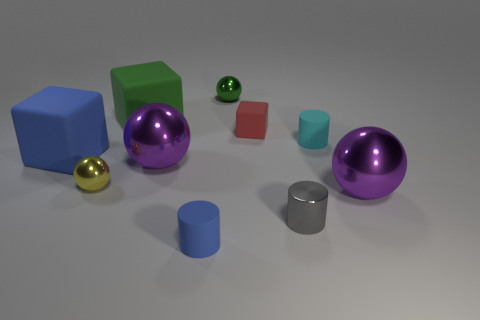Subtract all tiny blue rubber cylinders. How many cylinders are left? 2 Subtract 1 blocks. How many blocks are left? 2 Subtract all balls. How many objects are left? 6 Subtract all purple cylinders. How many purple balls are left? 2 Subtract all blue cylinders. How many cylinders are left? 2 Subtract all red blocks. Subtract all purple cylinders. How many blocks are left? 2 Subtract all tiny cyan objects. Subtract all cyan rubber cylinders. How many objects are left? 8 Add 1 gray metal cylinders. How many gray metal cylinders are left? 2 Add 8 small gray matte cylinders. How many small gray matte cylinders exist? 8 Subtract 0 blue balls. How many objects are left? 10 